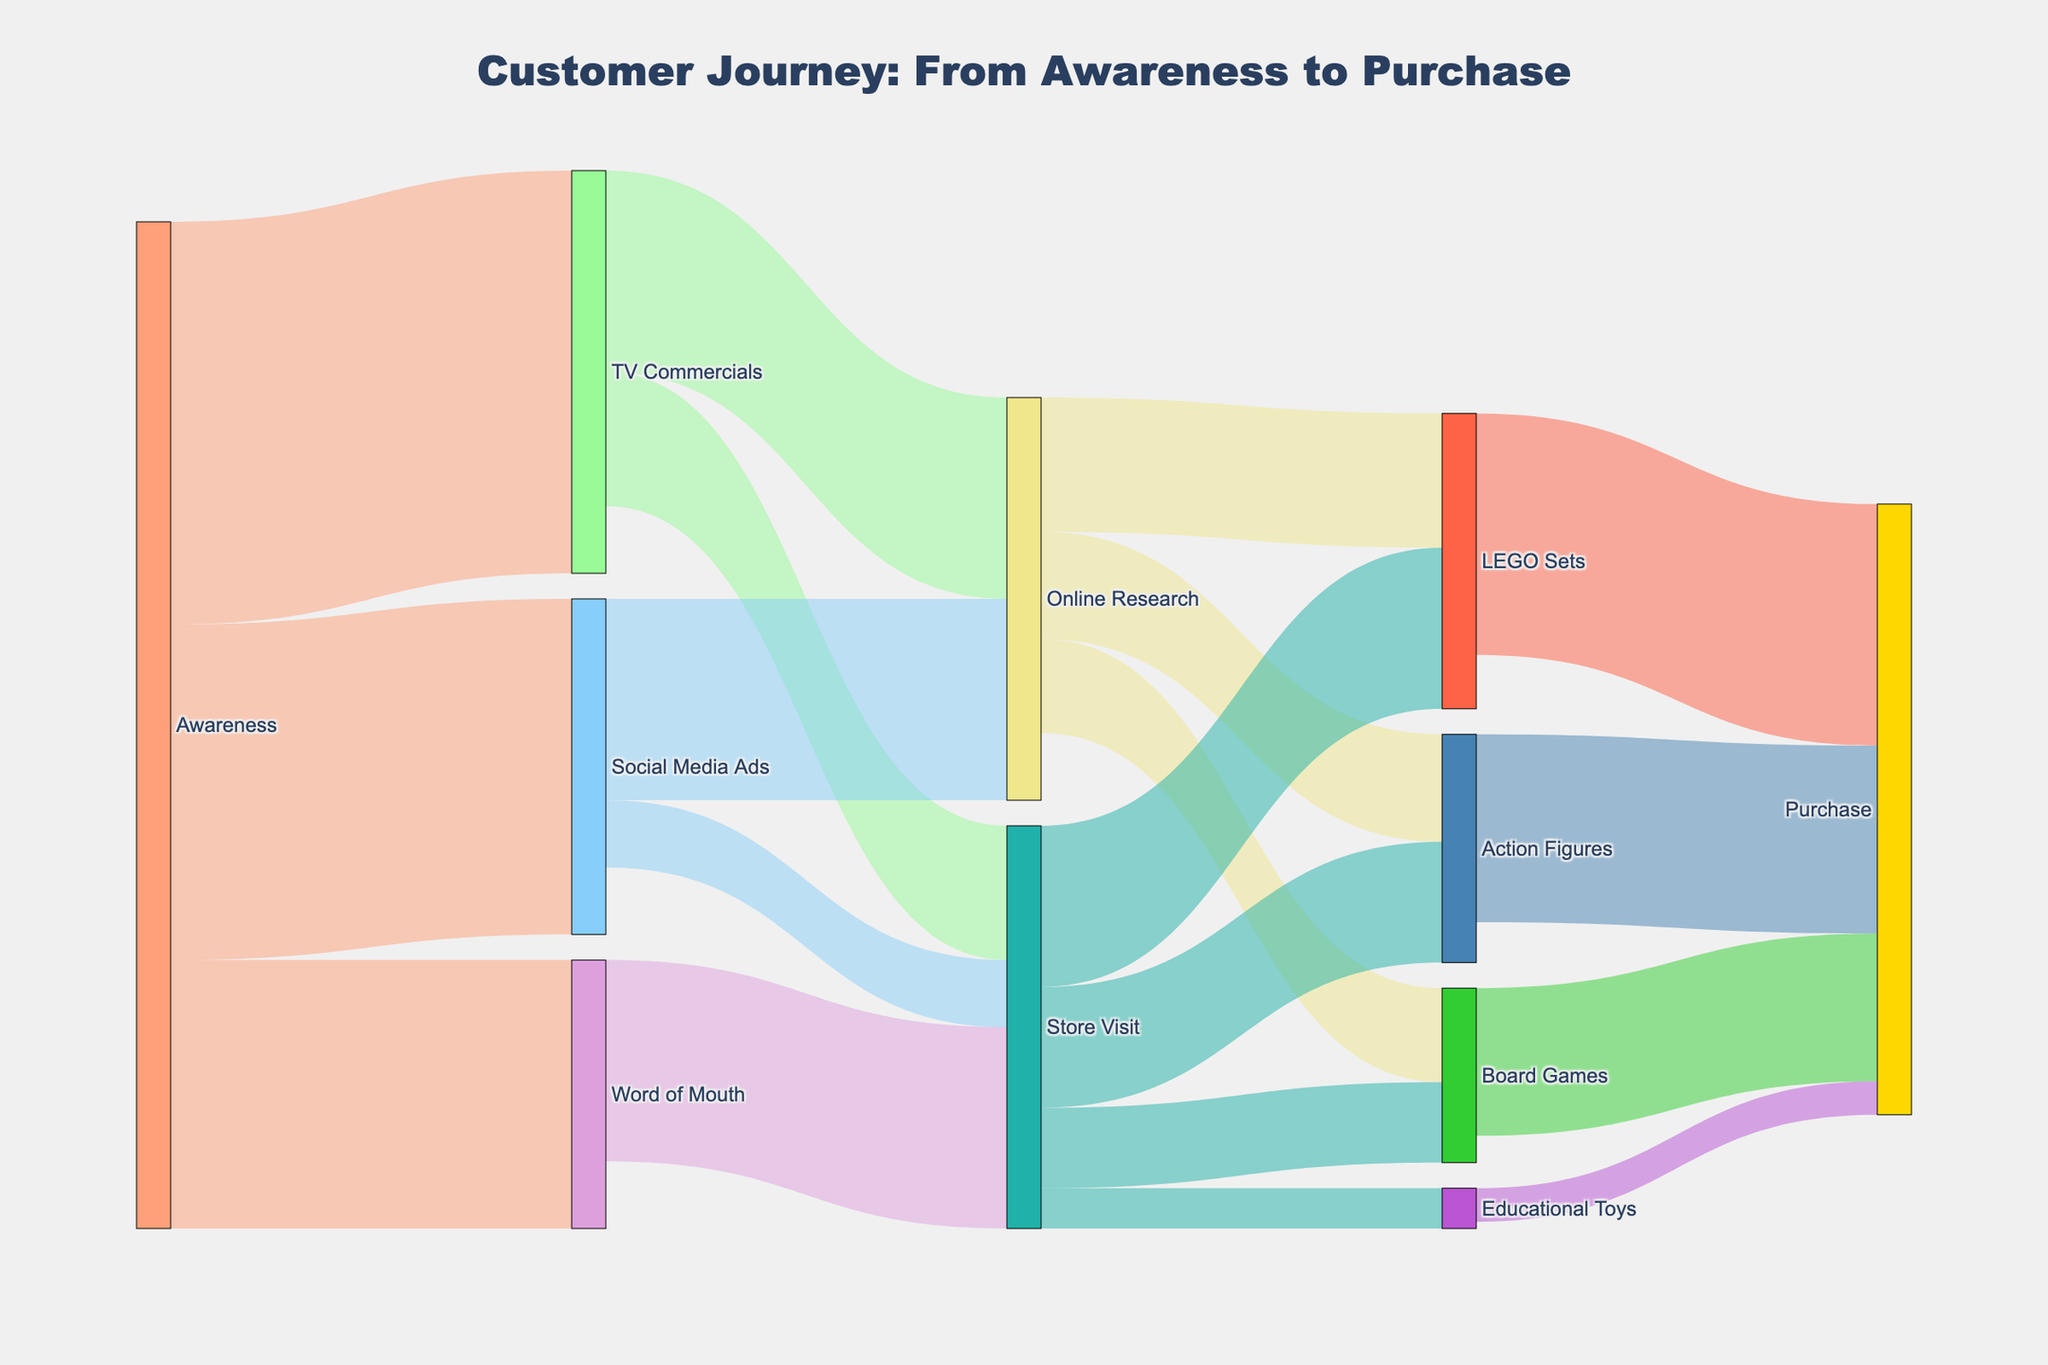what are the main sources of awareness? The Sankey diagram shows three main sources of awareness as labeled nodes: TV Commercials, Social Media Ads, and Word of Mouth.
Answer: TV Commercials, Social Media Ads, Word of Mouth How many people transitioned from TV commercials to online research? The diagram indicates the flow from TV Commercials to Online Research, marked with a value of 150.
Answer: 150 Which toy category has the highest number of purchases? By examining the flows leading to the Purchase node, LEGO Sets have the largest flow value of 180.
Answer: LEGO Sets How many total flows lead to store visits? Add the values leading to Store Visit: from TV Commercials (100), Social Media Ads (50), and Word of Mouth (150), summing them gives 300.
Answer: 300 What is the total number of people who transitioned from awareness to store visit? The sum of incoming flows to Store Visit is derived from TV Commercials (100), Social Media Ads (50), and Word of Mouth (150) is 100 + 50 + 150 = 300.
Answer: 300 What fraction of people doing online research purchased action figures? From Online Research, 80 people went to Action Figures and 150 + 150 = 300 people reached Purchase, giving the fraction 80/300. Simplified, this is approximately 0.27.
Answer: 0.27 What is the second most popular toy category in terms of purchases? By comparing the purchase flows: Action Figures have 140, which is second highest after LEGO Sets with 180.
Answer: Action Figures Which source of awareness leads to the most direct store visits? Examining direct transitions to Store Visit, Word of Mouth has the highest value of 150.
Answer: Word of Mouth Did more people do their research online or visit the store from social media ads? From Social Media Ads, 150 transitioned to Online Research and 50 to Store Visit, so more went to Online Research.
Answer: Online Research How many final purchases result from store visits? Summing the flows from Store Visit to all toy categories reaching Purchase: LEGO Sets (120), Action Figures (90), Board Games (60), Educational Toys (30) total 120 + 90 + 60 + 30 = 300.
Answer: 300 